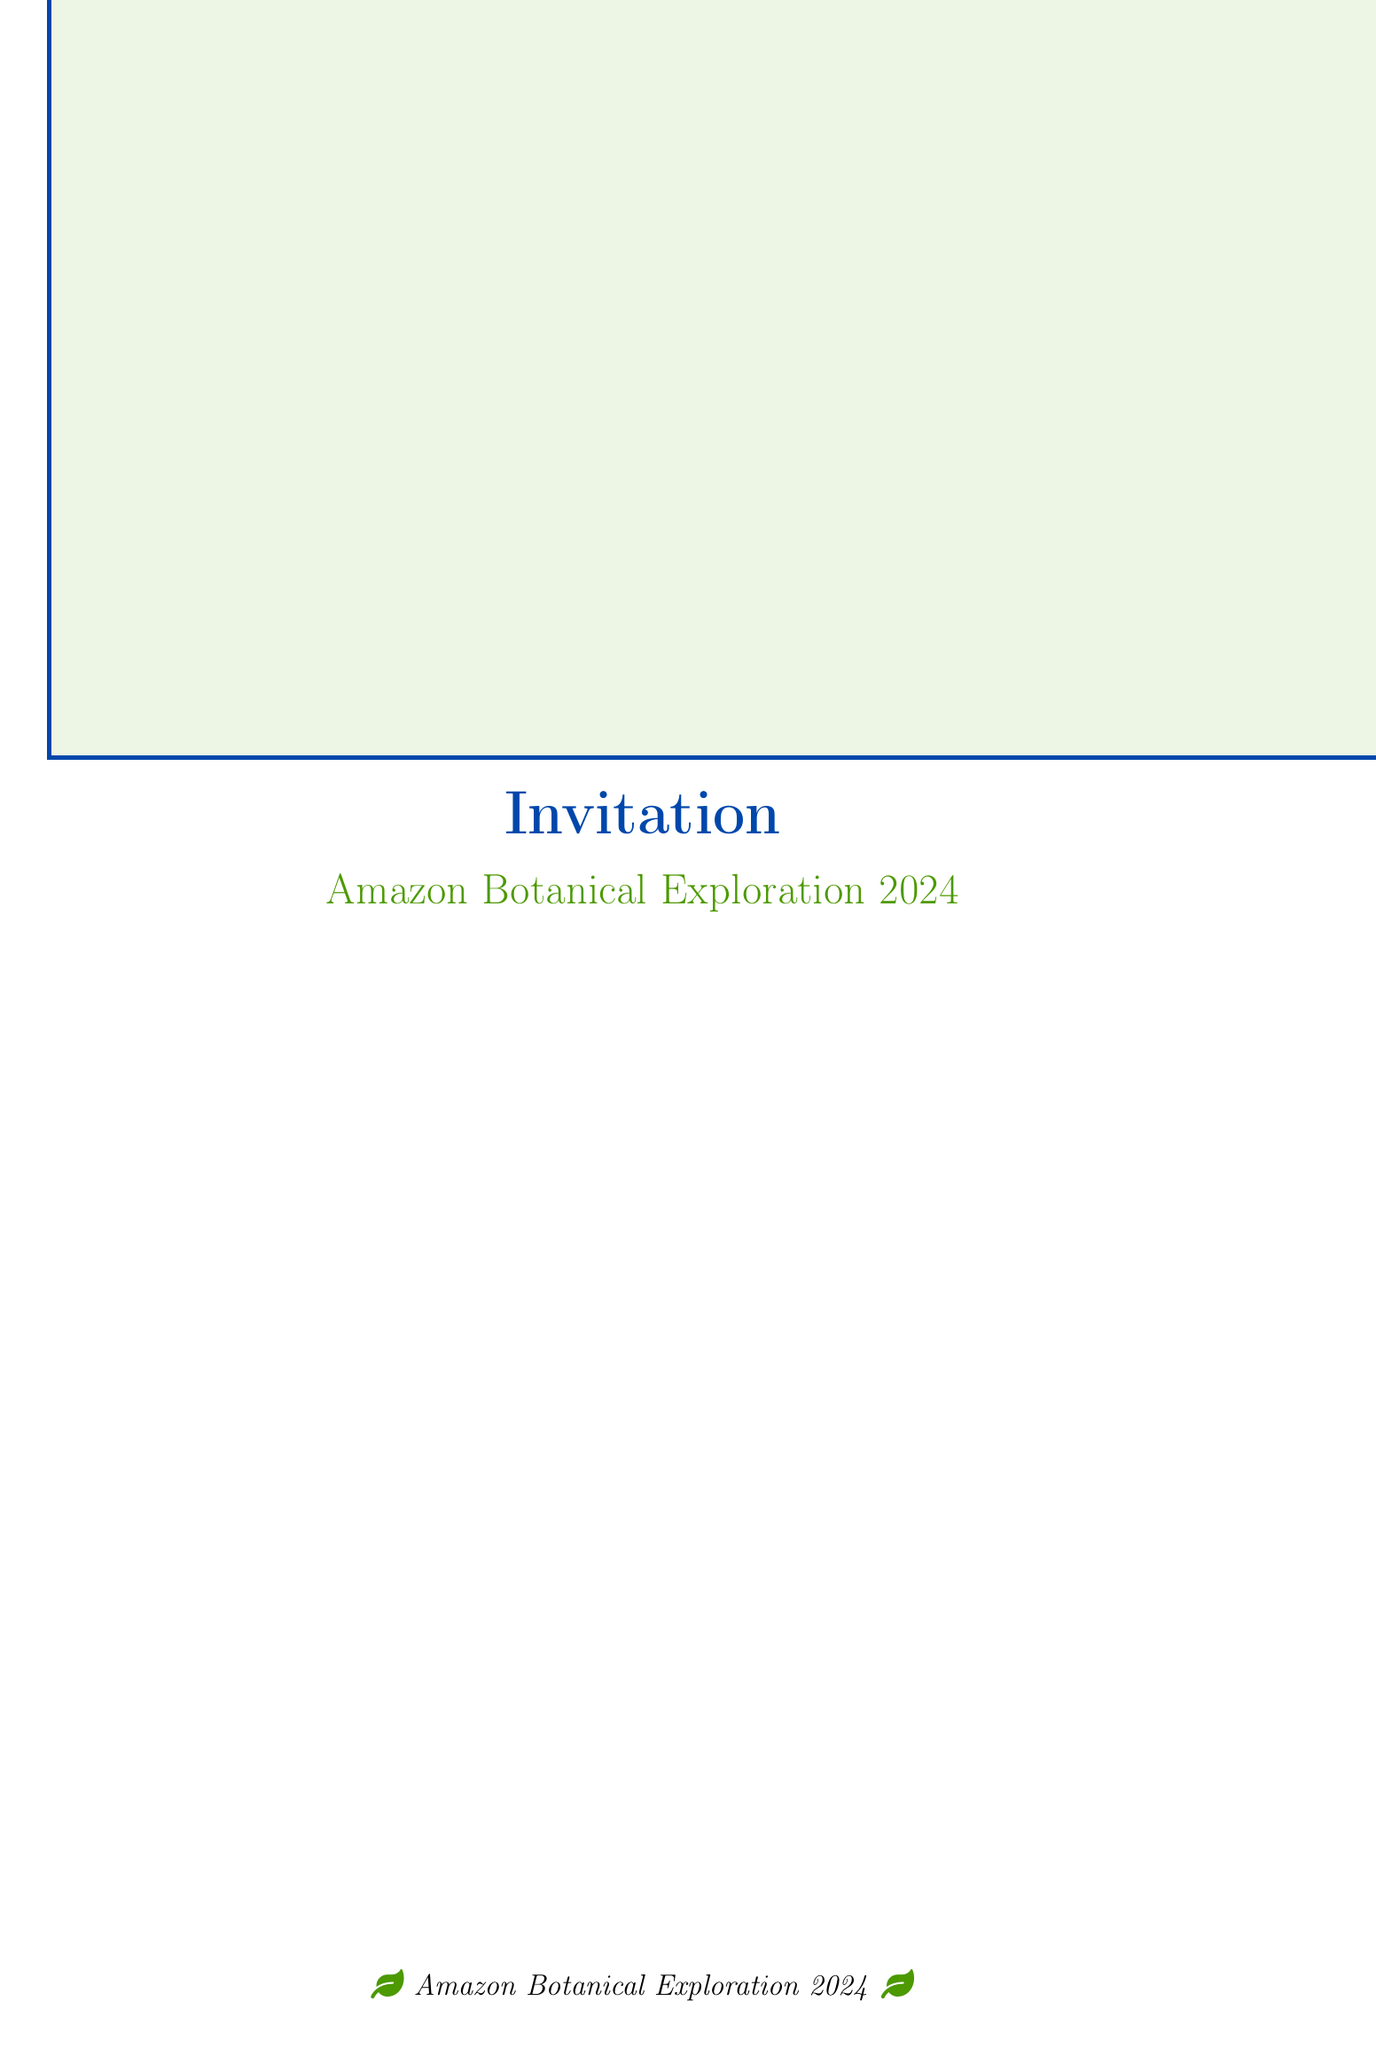What is the name of the expedition? The name of the expedition is stated prominently in the document as "Amazon Botanical Exploration 2024".
Answer: Amazon Botanical Exploration 2024 Who is the lead botanist? The lead botanist is mentioned in the document as Dr. Maria Fernandez.
Answer: Dr. Maria Fernandez What is the start date of the expedition? The start date is specifically provided in the expedition details section, which indicates when the expedition begins.
Answer: June 15, 2024 What is one potential new plant discovery related to medicinal properties? The document lists specific potential discoveries, including a Liana with potential anti-cancer properties.
Answer: Novel compound with potential anti-cancer properties How long is the expedition planned to last? The duration of the expedition is provided in the expedition details and specifies how long participants will be involved.
Answer: 6 weeks What institution is supporting the expedition? A supporting institution is mentioned in the document that is involved with the organization of the expedition.
Answer: Brazilian Institute of Botany What type of collaborative opportunities are available? The document outlines several collaborative opportunities available to participants, one of which is mentioned explicitly.
Answer: Co-authorship on scientific papers What aspect of the expedition focuses on community interaction? The conservation aspect mentioned in the document addresses the importance of local community engagement.
Answer: Engage with local communities for sustainable botanical resource management 